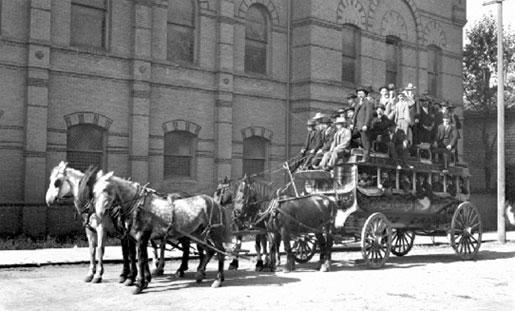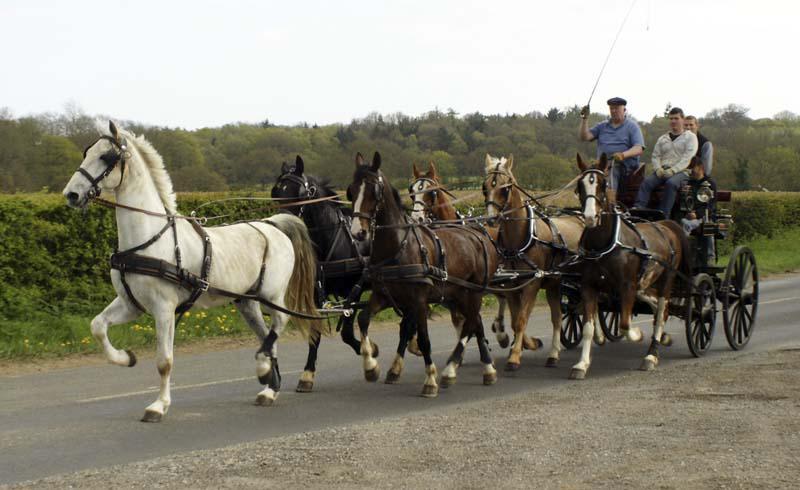The first image is the image on the left, the second image is the image on the right. For the images shown, is this caption "There are more than five white horses in one of the images." true? Answer yes or no. No. The first image is the image on the left, the second image is the image on the right. Considering the images on both sides, is "A man is riding a horse pulled sleigh through the snow in the right image." valid? Answer yes or no. No. 